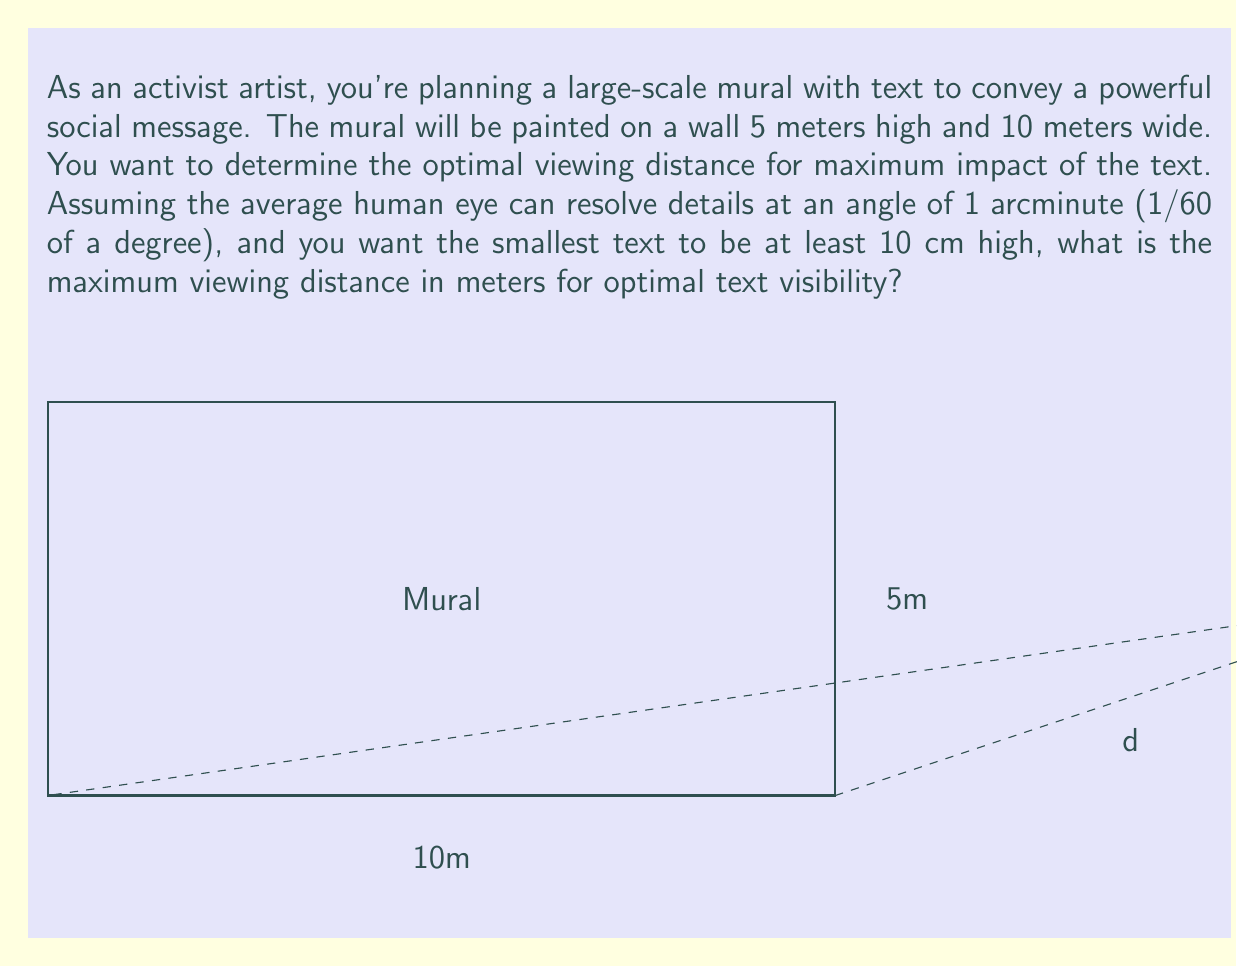Show me your answer to this math problem. To solve this problem, we'll use the concept of visual angle and the properties of similar triangles. Let's approach this step-by-step:

1) The visual angle θ (in radians) is given by:
   $$θ = \frac{h}{d}$$
   where h is the height of the object and d is the viewing distance.

2) We're given that the human eye can resolve details at 1 arcminute = 1/60 degree. Let's convert this to radians:
   $$θ_{min} = \frac{1}{60} \cdot \frac{\pi}{180} ≈ 0.0002909 \text{ radians}$$

3) The smallest text height is 10 cm = 0.1 m. We want this to be visible at the maximum distance d. Using the visual angle formula:
   $$0.0002909 = \frac{0.1}{d}$$

4) Solving for d:
   $$d = \frac{0.1}{0.0002909} ≈ 343.76 \text{ meters}$$

5) However, this is the theoretical maximum. In practice, we want to ensure comfortable visibility. A common rule of thumb is to use about 1/3 of this distance for optimal viewing. So:
   $$d_{optimal} = \frac{343.76}{3} ≈ 114.59 \text{ meters}$$

6) Rounding to a practical distance:
   $$d_{optimal} ≈ 115 \text{ meters}$$

This distance ensures that even the smallest text (10 cm high) will be comfortably visible to the average viewer, while allowing them to take in the entire mural (5m x 10m) in their field of view.
Answer: 115 meters 